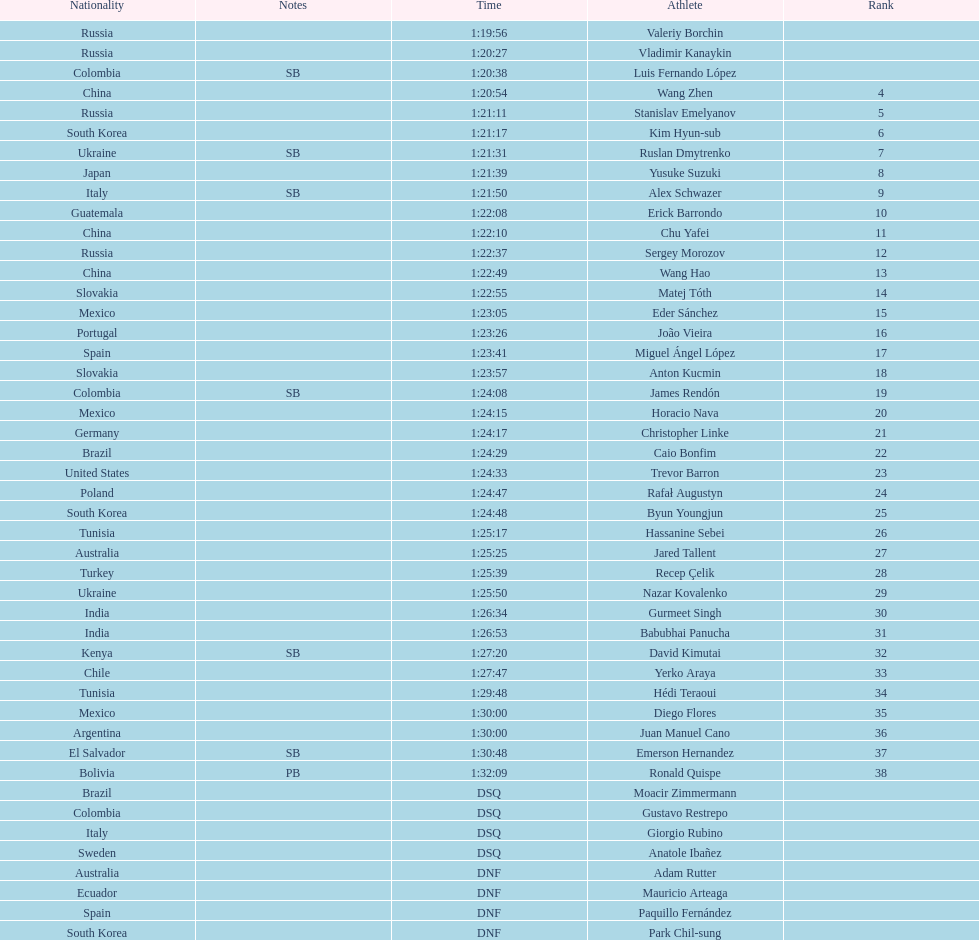Wang zhen and wang hao were both from which country? China. Help me parse the entirety of this table. {'header': ['Nationality', 'Notes', 'Time', 'Athlete', 'Rank'], 'rows': [['Russia', '', '1:19:56', 'Valeriy Borchin', ''], ['Russia', '', '1:20:27', 'Vladimir Kanaykin', ''], ['Colombia', 'SB', '1:20:38', 'Luis Fernando López', ''], ['China', '', '1:20:54', 'Wang Zhen', '4'], ['Russia', '', '1:21:11', 'Stanislav Emelyanov', '5'], ['South Korea', '', '1:21:17', 'Kim Hyun-sub', '6'], ['Ukraine', 'SB', '1:21:31', 'Ruslan Dmytrenko', '7'], ['Japan', '', '1:21:39', 'Yusuke Suzuki', '8'], ['Italy', 'SB', '1:21:50', 'Alex Schwazer', '9'], ['Guatemala', '', '1:22:08', 'Erick Barrondo', '10'], ['China', '', '1:22:10', 'Chu Yafei', '11'], ['Russia', '', '1:22:37', 'Sergey Morozov', '12'], ['China', '', '1:22:49', 'Wang Hao', '13'], ['Slovakia', '', '1:22:55', 'Matej Tóth', '14'], ['Mexico', '', '1:23:05', 'Eder Sánchez', '15'], ['Portugal', '', '1:23:26', 'João Vieira', '16'], ['Spain', '', '1:23:41', 'Miguel Ángel López', '17'], ['Slovakia', '', '1:23:57', 'Anton Kucmin', '18'], ['Colombia', 'SB', '1:24:08', 'James Rendón', '19'], ['Mexico', '', '1:24:15', 'Horacio Nava', '20'], ['Germany', '', '1:24:17', 'Christopher Linke', '21'], ['Brazil', '', '1:24:29', 'Caio Bonfim', '22'], ['United States', '', '1:24:33', 'Trevor Barron', '23'], ['Poland', '', '1:24:47', 'Rafał Augustyn', '24'], ['South Korea', '', '1:24:48', 'Byun Youngjun', '25'], ['Tunisia', '', '1:25:17', 'Hassanine Sebei', '26'], ['Australia', '', '1:25:25', 'Jared Tallent', '27'], ['Turkey', '', '1:25:39', 'Recep Çelik', '28'], ['Ukraine', '', '1:25:50', 'Nazar Kovalenko', '29'], ['India', '', '1:26:34', 'Gurmeet Singh', '30'], ['India', '', '1:26:53', 'Babubhai Panucha', '31'], ['Kenya', 'SB', '1:27:20', 'David Kimutai', '32'], ['Chile', '', '1:27:47', 'Yerko Araya', '33'], ['Tunisia', '', '1:29:48', 'Hédi Teraoui', '34'], ['Mexico', '', '1:30:00', 'Diego Flores', '35'], ['Argentina', '', '1:30:00', 'Juan Manuel Cano', '36'], ['El Salvador', 'SB', '1:30:48', 'Emerson Hernandez', '37'], ['Bolivia', 'PB', '1:32:09', 'Ronald Quispe', '38'], ['Brazil', '', 'DSQ', 'Moacir Zimmermann', ''], ['Colombia', '', 'DSQ', 'Gustavo Restrepo', ''], ['Italy', '', 'DSQ', 'Giorgio Rubino', ''], ['Sweden', '', 'DSQ', 'Anatole Ibañez', ''], ['Australia', '', 'DNF', 'Adam Rutter', ''], ['Ecuador', '', 'DNF', 'Mauricio Arteaga', ''], ['Spain', '', 'DNF', 'Paquillo Fernández', ''], ['South Korea', '', 'DNF', 'Park Chil-sung', '']]} 